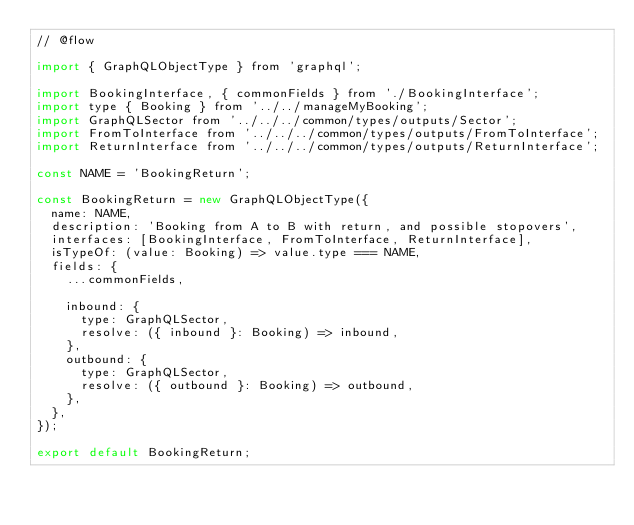<code> <loc_0><loc_0><loc_500><loc_500><_JavaScript_>// @flow

import { GraphQLObjectType } from 'graphql';

import BookingInterface, { commonFields } from './BookingInterface';
import type { Booking } from '../../manageMyBooking';
import GraphQLSector from '../../../common/types/outputs/Sector';
import FromToInterface from '../../../common/types/outputs/FromToInterface';
import ReturnInterface from '../../../common/types/outputs/ReturnInterface';

const NAME = 'BookingReturn';

const BookingReturn = new GraphQLObjectType({
  name: NAME,
  description: 'Booking from A to B with return, and possible stopovers',
  interfaces: [BookingInterface, FromToInterface, ReturnInterface],
  isTypeOf: (value: Booking) => value.type === NAME,
  fields: {
    ...commonFields,

    inbound: {
      type: GraphQLSector,
      resolve: ({ inbound }: Booking) => inbound,
    },
    outbound: {
      type: GraphQLSector,
      resolve: ({ outbound }: Booking) => outbound,
    },
  },
});

export default BookingReturn;
</code> 